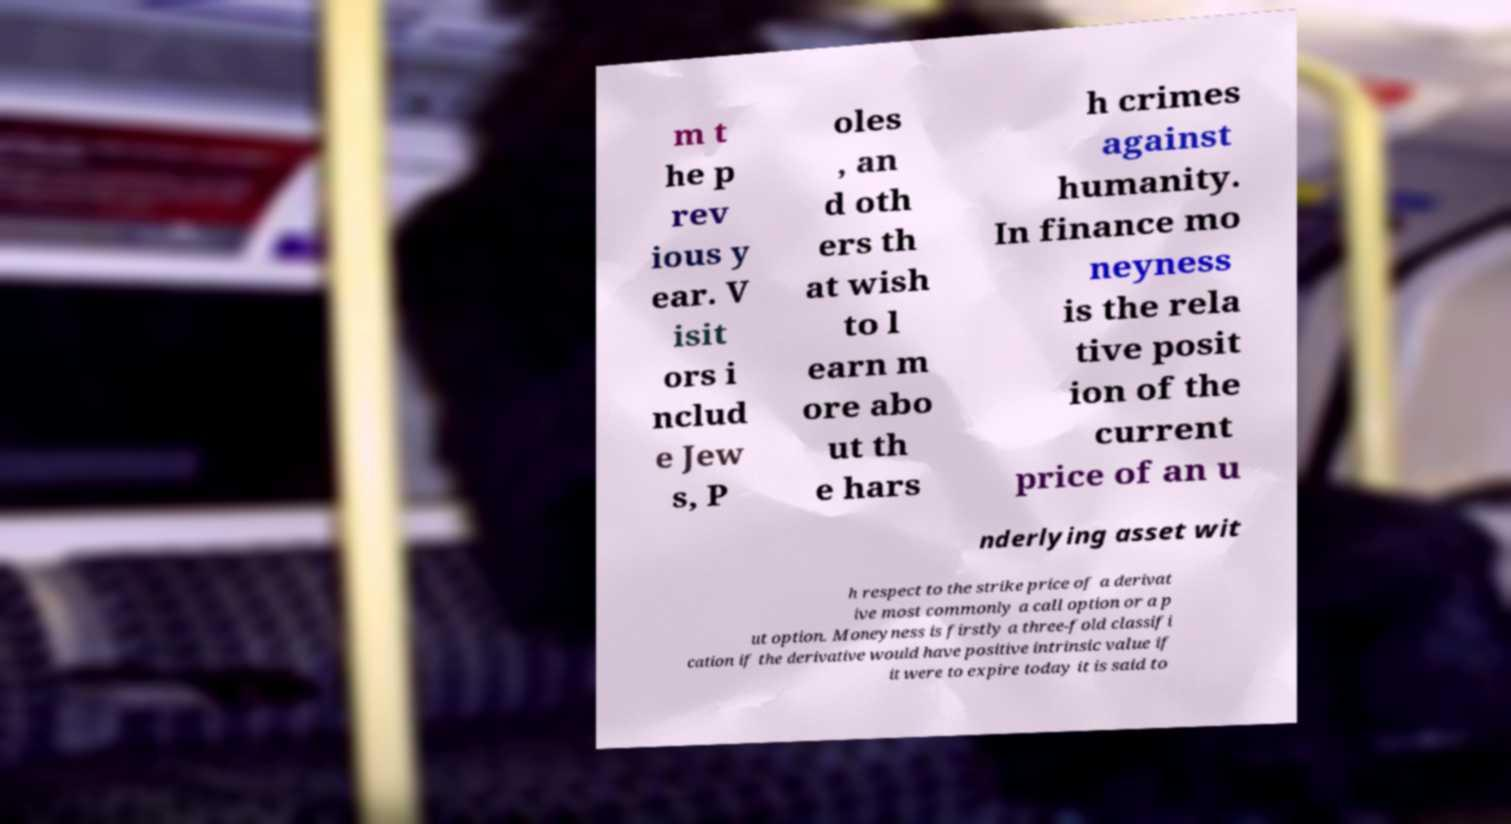There's text embedded in this image that I need extracted. Can you transcribe it verbatim? m t he p rev ious y ear. V isit ors i nclud e Jew s, P oles , an d oth ers th at wish to l earn m ore abo ut th e hars h crimes against humanity. In finance mo neyness is the rela tive posit ion of the current price of an u nderlying asset wit h respect to the strike price of a derivat ive most commonly a call option or a p ut option. Moneyness is firstly a three-fold classifi cation if the derivative would have positive intrinsic value if it were to expire today it is said to 